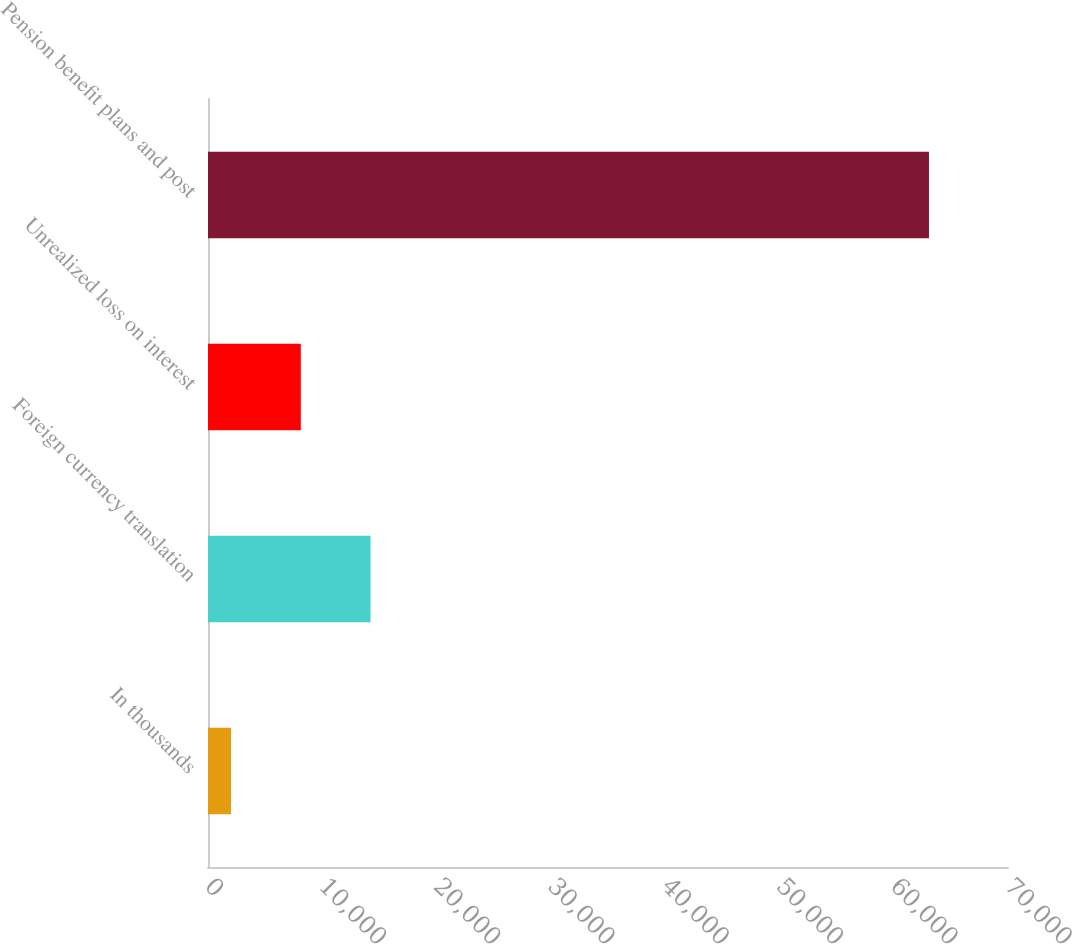<chart> <loc_0><loc_0><loc_500><loc_500><bar_chart><fcel>In thousands<fcel>Foreign currency translation<fcel>Unrealized loss on interest<fcel>Pension benefit plans and post<nl><fcel>2012<fcel>14226.8<fcel>8119.4<fcel>63086<nl></chart> 